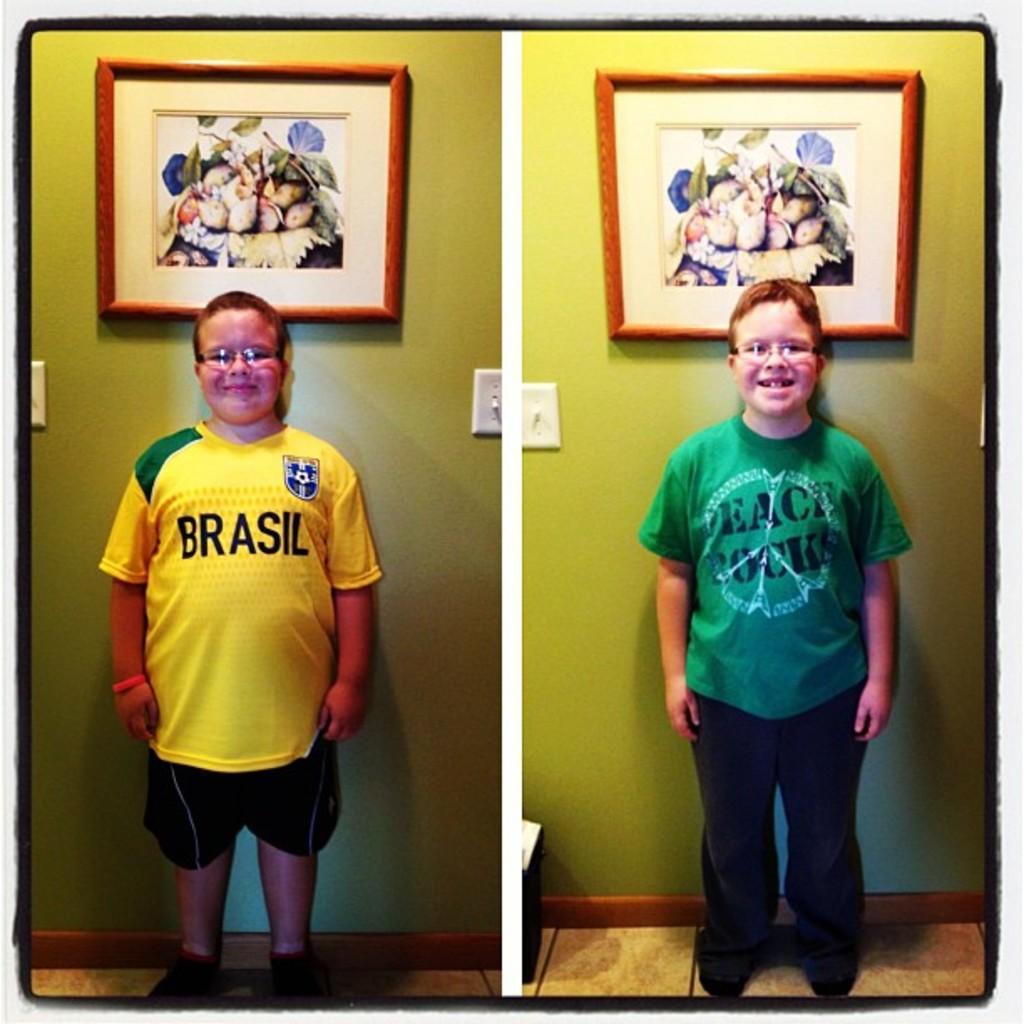Can you describe this image briefly? In this image on the left side I can see a boy wearing a yellow color t-shirt and standing in front of the green color wall and on the wall I can see a photo frame and on the right side I can see a boy wearing a green color standing in front the wall and on the wall I can see a photo frame attached. 